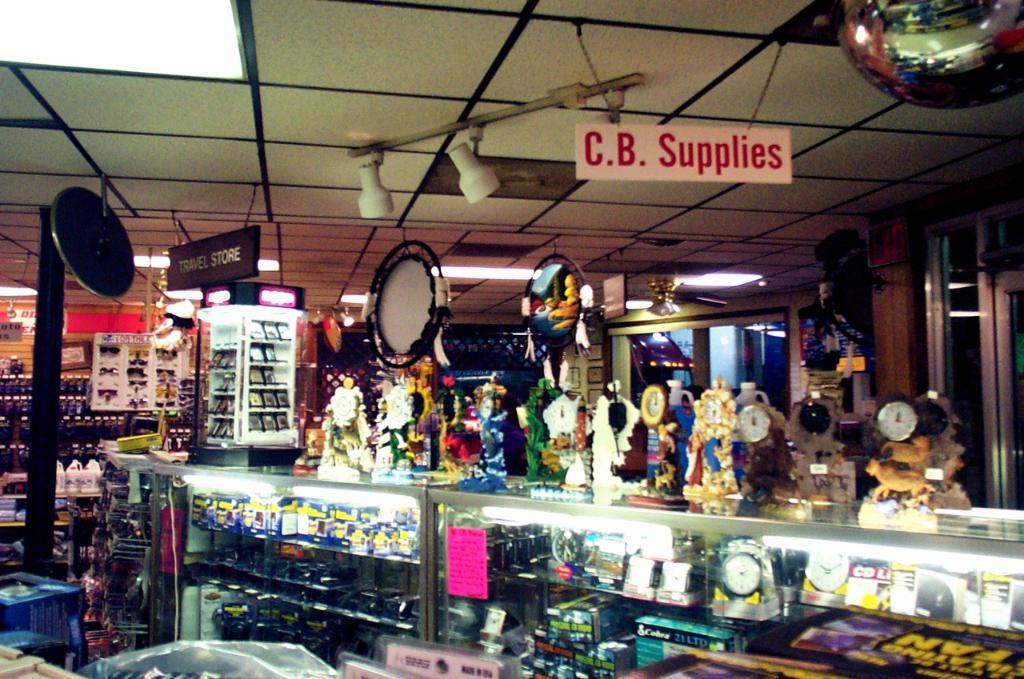<image>
Share a concise interpretation of the image provided. A display case featuring some sort of fashion or jewelry accessories under a sign that reads "C.B. Supplies" 